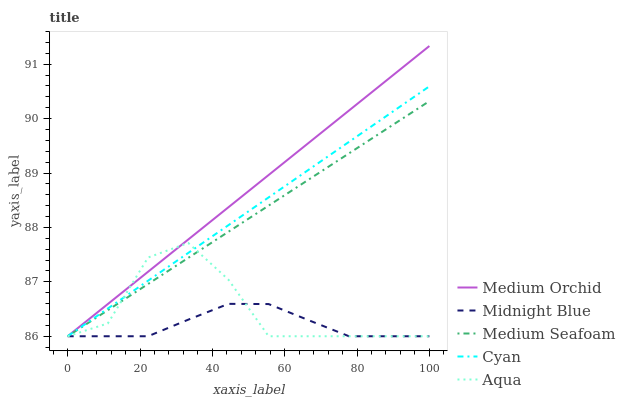Does Midnight Blue have the minimum area under the curve?
Answer yes or no. Yes. Does Medium Orchid have the maximum area under the curve?
Answer yes or no. Yes. Does Aqua have the minimum area under the curve?
Answer yes or no. No. Does Aqua have the maximum area under the curve?
Answer yes or no. No. Is Cyan the smoothest?
Answer yes or no. Yes. Is Aqua the roughest?
Answer yes or no. Yes. Is Medium Orchid the smoothest?
Answer yes or no. No. Is Medium Orchid the roughest?
Answer yes or no. No. Does Cyan have the lowest value?
Answer yes or no. Yes. Does Medium Orchid have the highest value?
Answer yes or no. Yes. Does Aqua have the highest value?
Answer yes or no. No. Does Cyan intersect Medium Seafoam?
Answer yes or no. Yes. Is Cyan less than Medium Seafoam?
Answer yes or no. No. Is Cyan greater than Medium Seafoam?
Answer yes or no. No. 